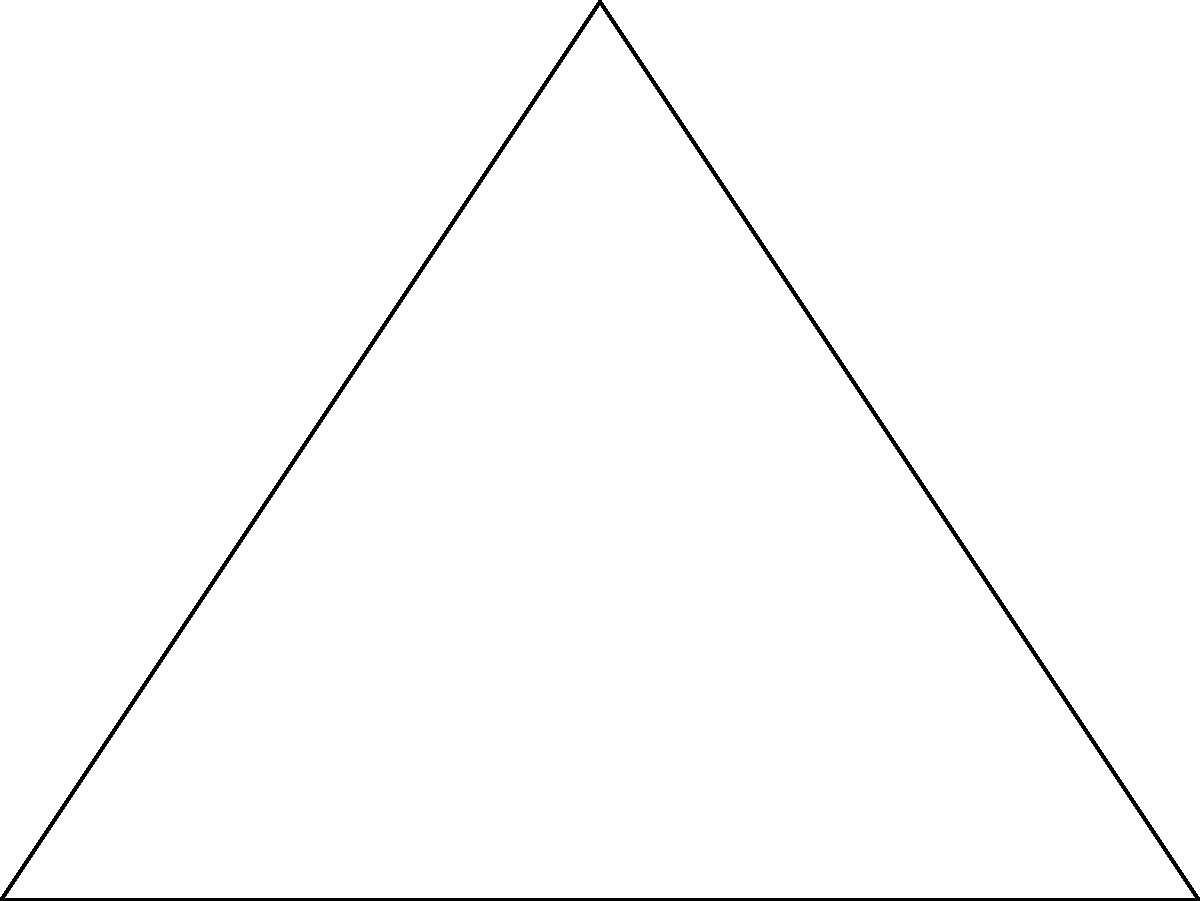In a triangulation survey of a protected wildlife habitat, three observation points A, B, and C form a right-angled triangle. The distance between A and B is 4 km, and the distance between A and C is 3 km. What is the area of the triangular region formed by these observation points? To find the area of the triangular region, we can follow these steps:

1) We are given a right-angled triangle with:
   - The base (AB) = 4 km
   - The height (AC) = 3 km

2) The formula for the area of a triangle is:
   $$Area = \frac{1}{2} \times base \times height$$

3) Substituting our known values:
   $$Area = \frac{1}{2} \times 4 \times 3$$

4) Simplifying:
   $$Area = \frac{1}{2} \times 12 = 6$$

Therefore, the area of the triangular region is 6 square kilometers.
Answer: 6 km² 